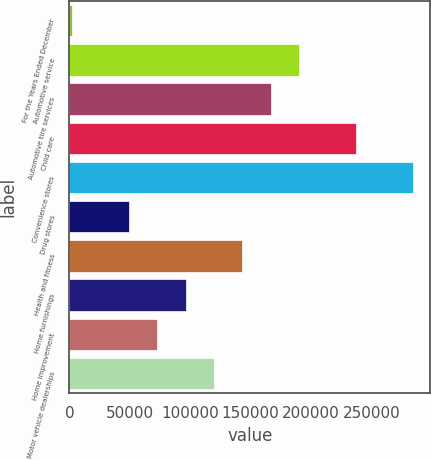Convert chart to OTSL. <chart><loc_0><loc_0><loc_500><loc_500><bar_chart><fcel>For the Years Ended December<fcel>Automotive service<fcel>Automotive tire services<fcel>Child care<fcel>Convenience stores<fcel>Drug stores<fcel>Health and fitness<fcel>Home furnishings<fcel>Home improvement<fcel>Motor vehicle dealerships<nl><fcel>2006<fcel>190334<fcel>166793<fcel>237416<fcel>284498<fcel>49088<fcel>143252<fcel>96170<fcel>72629<fcel>119711<nl></chart> 